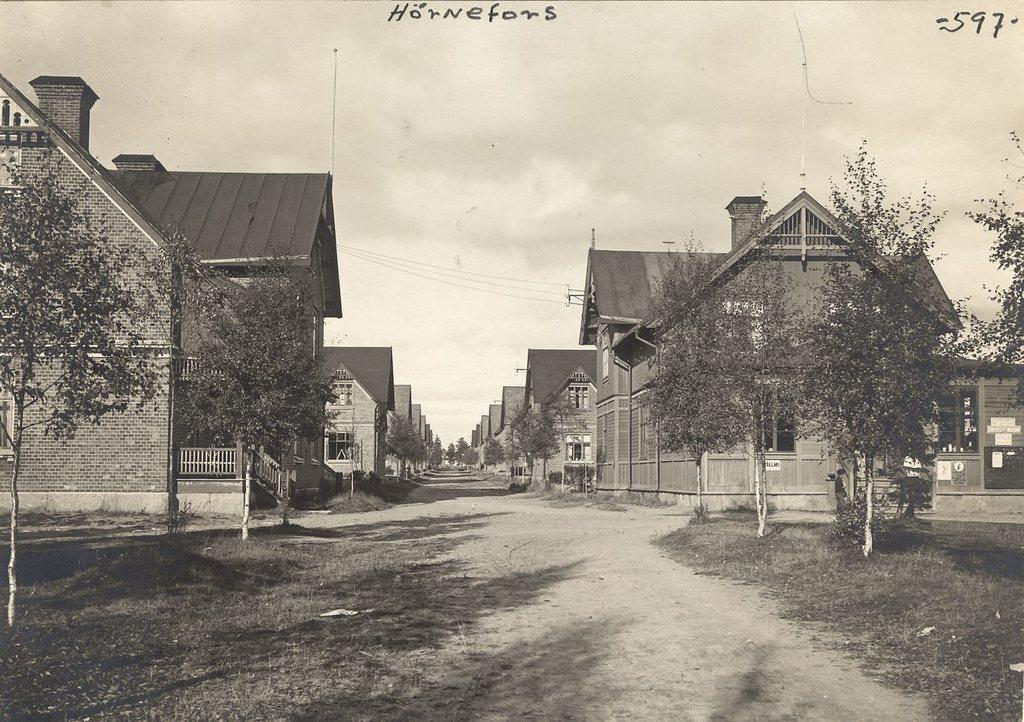What type of vegetation can be seen in the image? There is grass and trees in the image. What type of structures are visible in the image? There are buildings in the image. What type of barrier is present in the image? There is a fence in the image. What type of vertical structures are present in the image? There are poles in the image. Is there any text present in the image? Yes, there is text in the image. What part of the natural environment is visible in the image? The sky is visible in the image. Can you describe the setting where the image was taken? The image may have been taken on a road, as suggested by the presence of poles and the possible alignment of the buildings. How much income does the mountain generate in the image? There is no mountain present in the image, so it is not possible to determine its income. How many sheep are in the flock depicted in the image? There is no flock of sheep present in the image. 